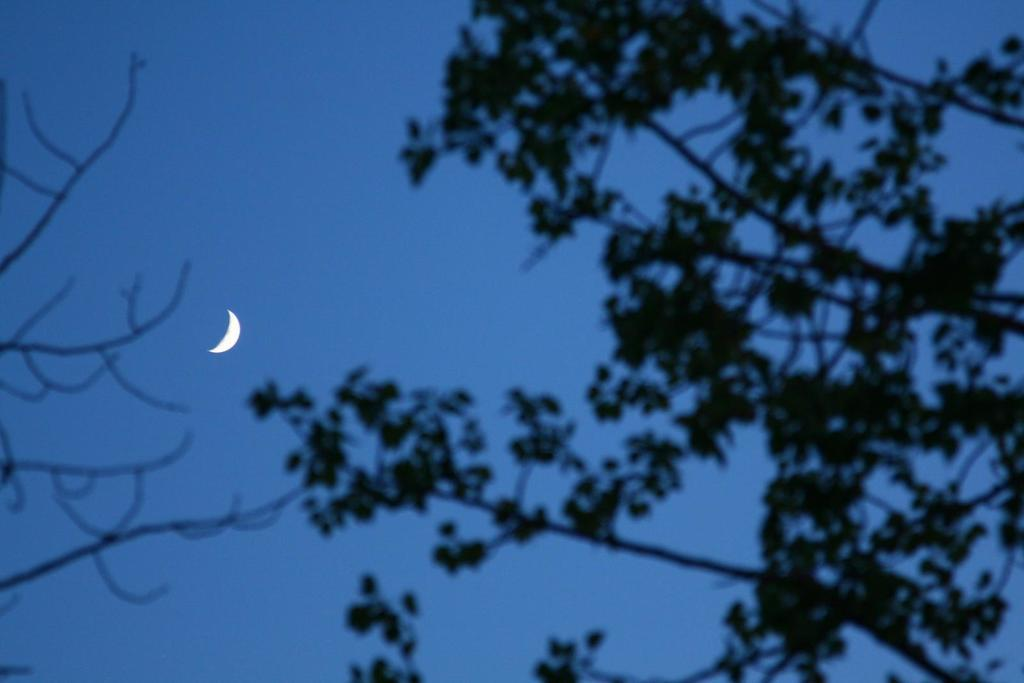What is in the foreground of the picture? There are branches of a tree in the foreground of the picture. What celestial body can be seen in the sky in the picture? The moon is visible in the sky in the center of the picture. What type of zebra can be seen playing with a circle-shaped board in the image? There is no zebra or board present in the image; it features branches of a tree and the moon in the sky. 